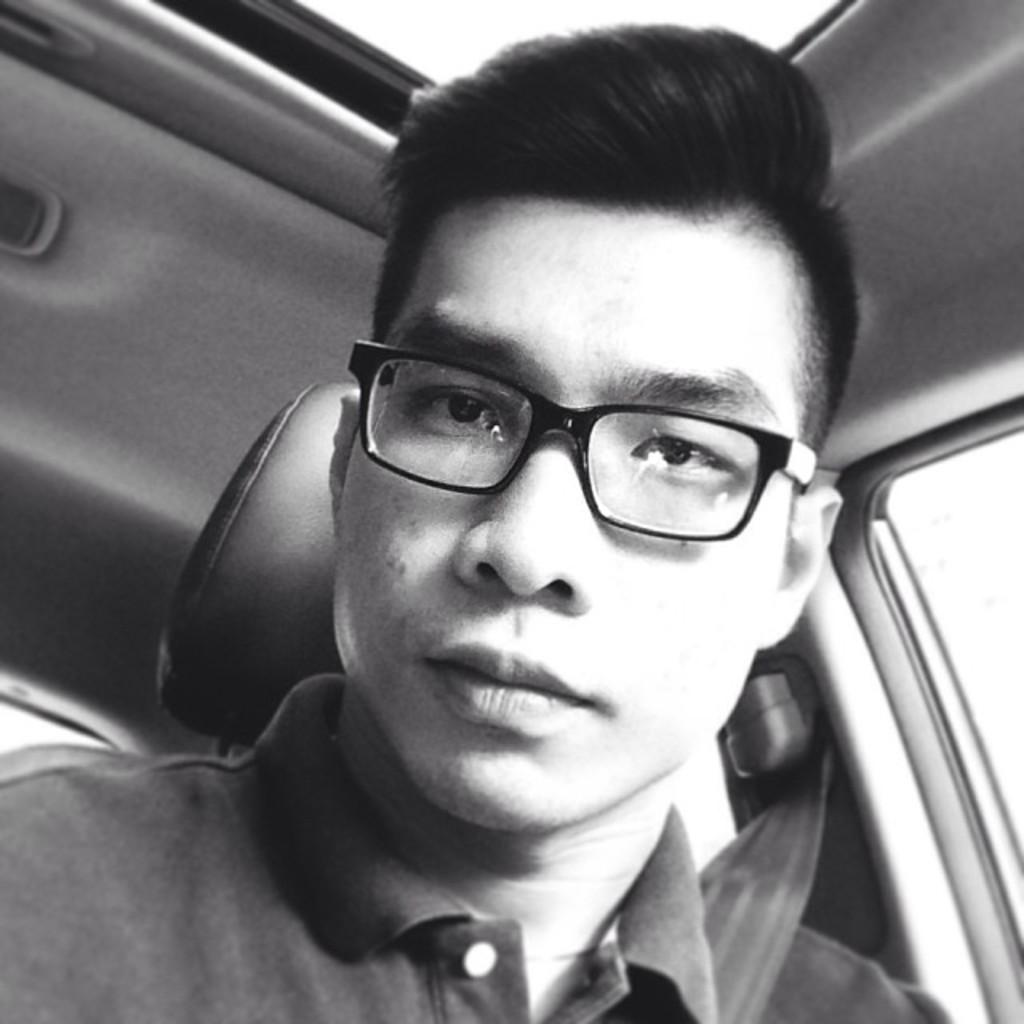What is the main subject of the image? There is a person in the image. Where is the person located? The person is in a vehicle. Where is the faucet located in the image? There is no faucet present in the image. What type of nest can be seen in the image? There is no nest present in the image. 